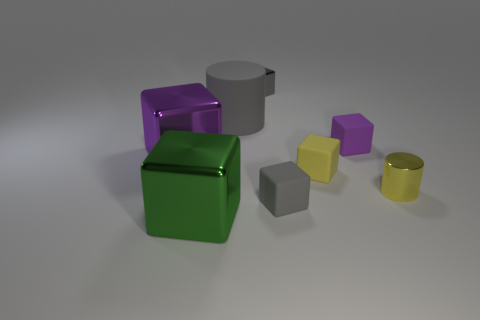What is the shape of the large object that is the same material as the yellow cube?
Offer a very short reply. Cylinder. There is a gray object on the left side of the small metallic cube; how big is it?
Offer a terse response. Large. Are there an equal number of cylinders that are on the left side of the yellow matte object and big gray objects on the left side of the big green block?
Offer a very short reply. No. The thing right of the small rubber object behind the large thing that is to the left of the green object is what color?
Offer a terse response. Yellow. How many metallic things are left of the small yellow cylinder and behind the large green block?
Provide a succinct answer. 2. Does the metallic block on the left side of the green block have the same color as the shiny thing on the right side of the small yellow block?
Your answer should be very brief. No. Are there any other things that are made of the same material as the small purple thing?
Make the answer very short. Yes. There is a yellow thing that is the same shape as the gray metal thing; what size is it?
Your response must be concise. Small. There is a purple rubber object; are there any tiny purple rubber things in front of it?
Your answer should be very brief. No. Are there the same number of metallic things that are left of the yellow metal object and yellow rubber blocks?
Give a very brief answer. No. 